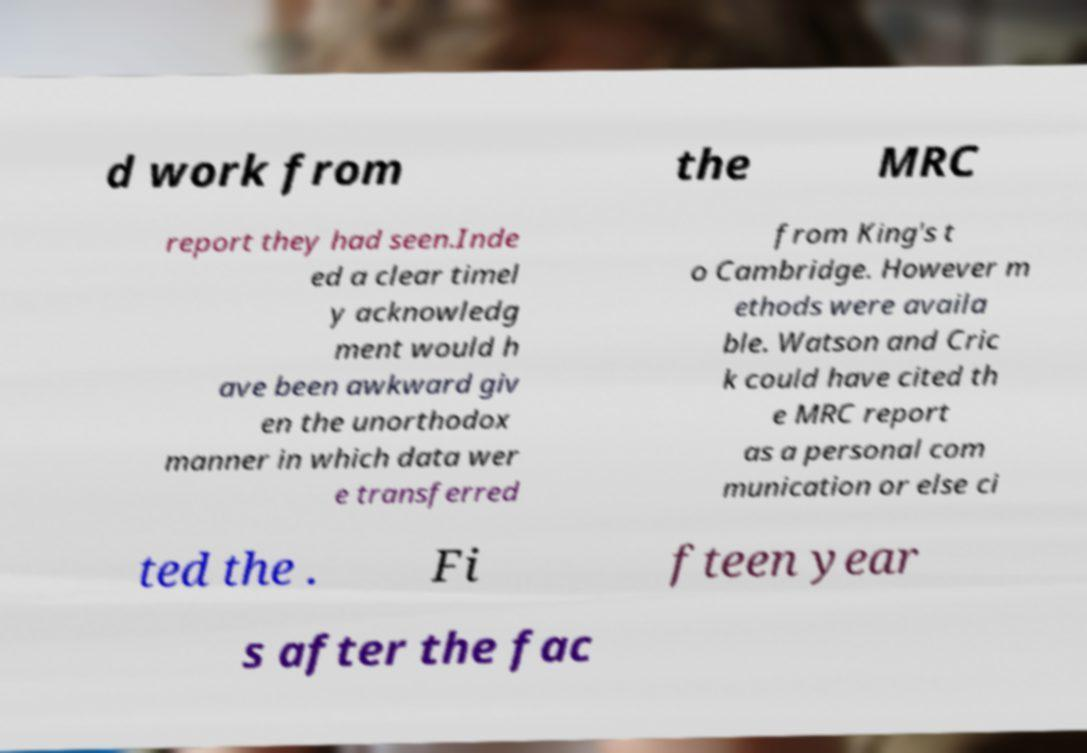What messages or text are displayed in this image? I need them in a readable, typed format. d work from the MRC report they had seen.Inde ed a clear timel y acknowledg ment would h ave been awkward giv en the unorthodox manner in which data wer e transferred from King's t o Cambridge. However m ethods were availa ble. Watson and Cric k could have cited th e MRC report as a personal com munication or else ci ted the . Fi fteen year s after the fac 